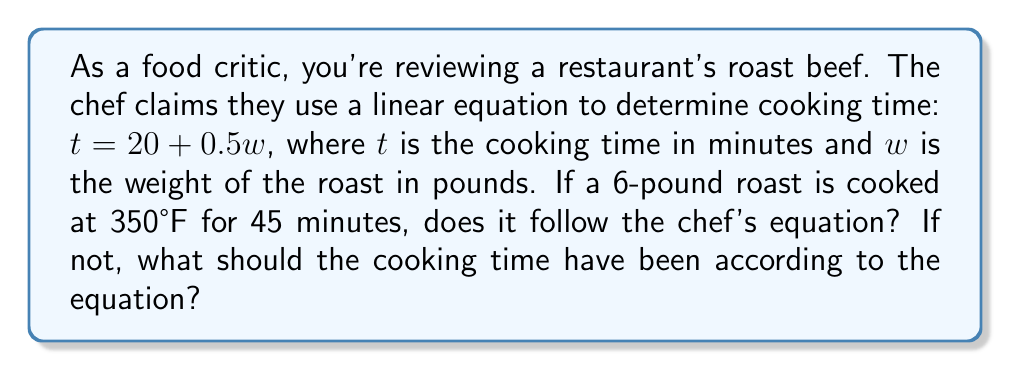Help me with this question. Let's approach this step-by-step:

1) The chef's equation is: $t = 20 + 0.5w$

2) We're given that $w = 6$ pounds and the actual cooking time was $t = 45$ minutes.

3) Let's plug $w = 6$ into the equation to see what the cooking time should have been:

   $t = 20 + 0.5(6)$
   $t = 20 + 3$
   $t = 23$ minutes

4) The equation predicts a cooking time of 23 minutes, but the actual cooking time was 45 minutes.

5) To determine if the roast follows the chef's equation:
   - If the actual cooking time (45 minutes) matches the calculated time (23 minutes), it follows the equation.
   - If they don't match, it doesn't follow the equation.

6) Clearly, 45 minutes ≠ 23 minutes, so the roast does not follow the chef's equation.

7) According to the chef's equation, the cooking time should have been 23 minutes.
Answer: No, 23 minutes 